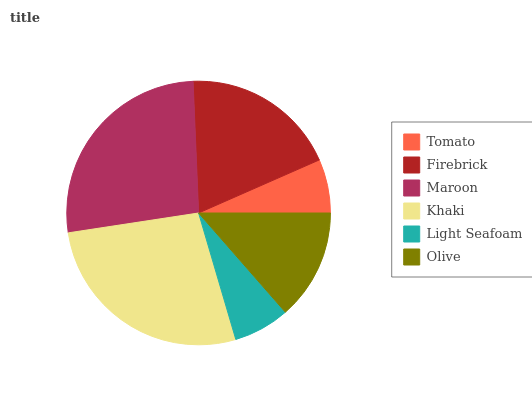Is Tomato the minimum?
Answer yes or no. Yes. Is Khaki the maximum?
Answer yes or no. Yes. Is Firebrick the minimum?
Answer yes or no. No. Is Firebrick the maximum?
Answer yes or no. No. Is Firebrick greater than Tomato?
Answer yes or no. Yes. Is Tomato less than Firebrick?
Answer yes or no. Yes. Is Tomato greater than Firebrick?
Answer yes or no. No. Is Firebrick less than Tomato?
Answer yes or no. No. Is Firebrick the high median?
Answer yes or no. Yes. Is Olive the low median?
Answer yes or no. Yes. Is Khaki the high median?
Answer yes or no. No. Is Firebrick the low median?
Answer yes or no. No. 